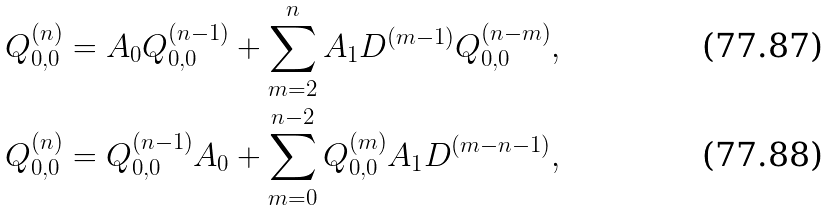Convert formula to latex. <formula><loc_0><loc_0><loc_500><loc_500>& Q _ { 0 , 0 } ^ { ( n ) } = A _ { 0 } Q _ { 0 , 0 } ^ { ( n - 1 ) } + \sum _ { m = 2 } ^ { n } A _ { 1 } D ^ { ( m - 1 ) } Q _ { 0 , 0 } ^ { ( n - m ) } , \\ & Q _ { 0 , 0 } ^ { ( n ) } = Q _ { 0 , 0 } ^ { ( n - 1 ) } A _ { 0 } + \sum _ { m = 0 } ^ { n - 2 } Q _ { 0 , 0 } ^ { ( m ) } A _ { 1 } D ^ { ( m - n - 1 ) } ,</formula> 